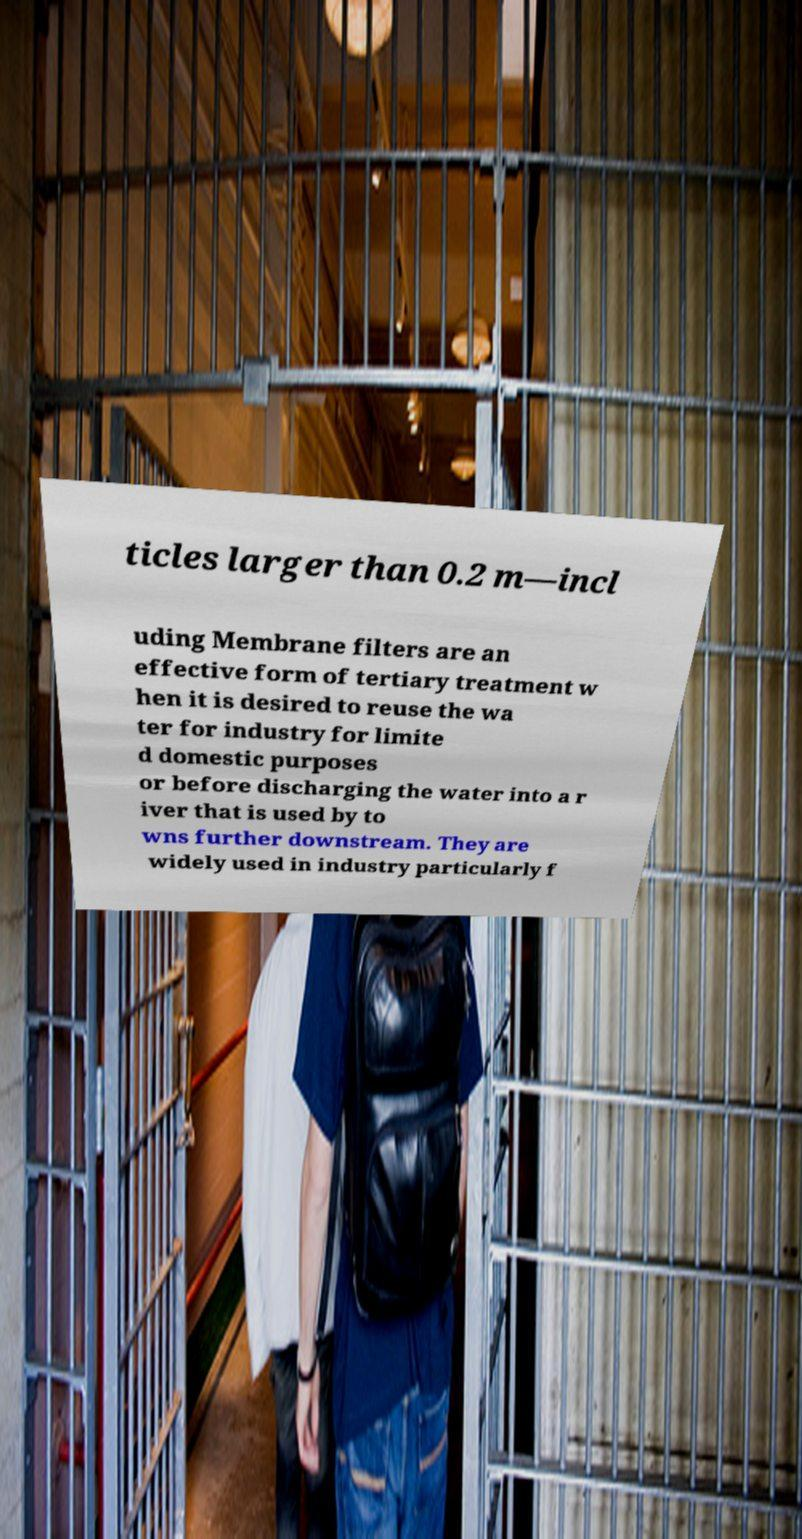There's text embedded in this image that I need extracted. Can you transcribe it verbatim? ticles larger than 0.2 m—incl uding Membrane filters are an effective form of tertiary treatment w hen it is desired to reuse the wa ter for industry for limite d domestic purposes or before discharging the water into a r iver that is used by to wns further downstream. They are widely used in industry particularly f 